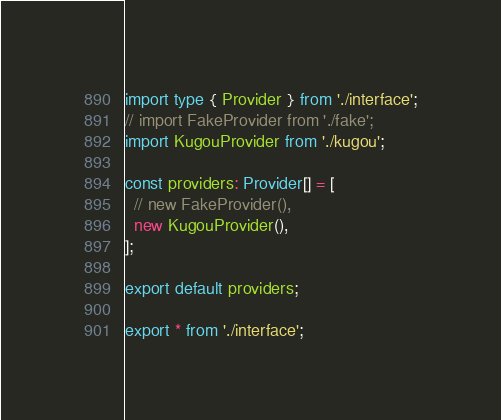<code> <loc_0><loc_0><loc_500><loc_500><_TypeScript_>import type { Provider } from './interface';
// import FakeProvider from './fake';
import KugouProvider from './kugou';

const providers: Provider[] = [
  // new FakeProvider(),
  new KugouProvider(),
];

export default providers;

export * from './interface';
</code> 